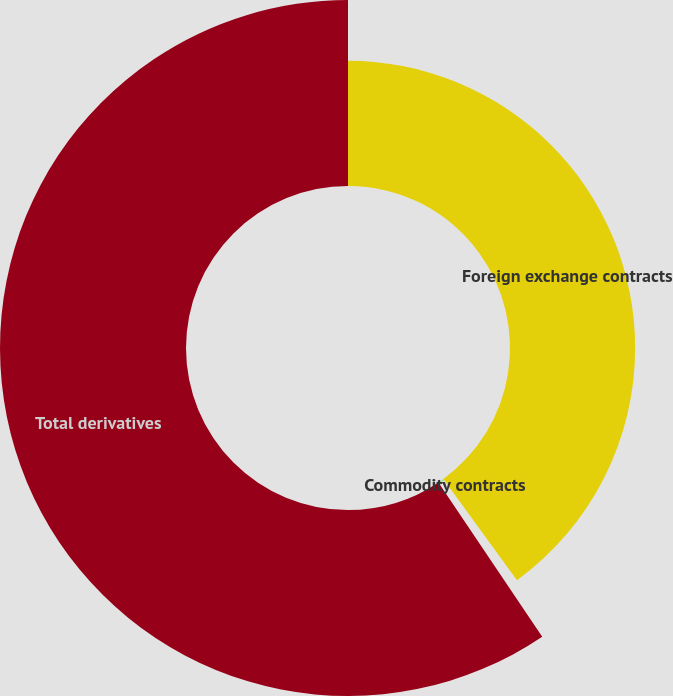Convert chart to OTSL. <chart><loc_0><loc_0><loc_500><loc_500><pie_chart><fcel>Foreign exchange contracts<fcel>Commodity contracts<fcel>Total derivatives<nl><fcel>39.99%<fcel>0.59%<fcel>59.43%<nl></chart> 